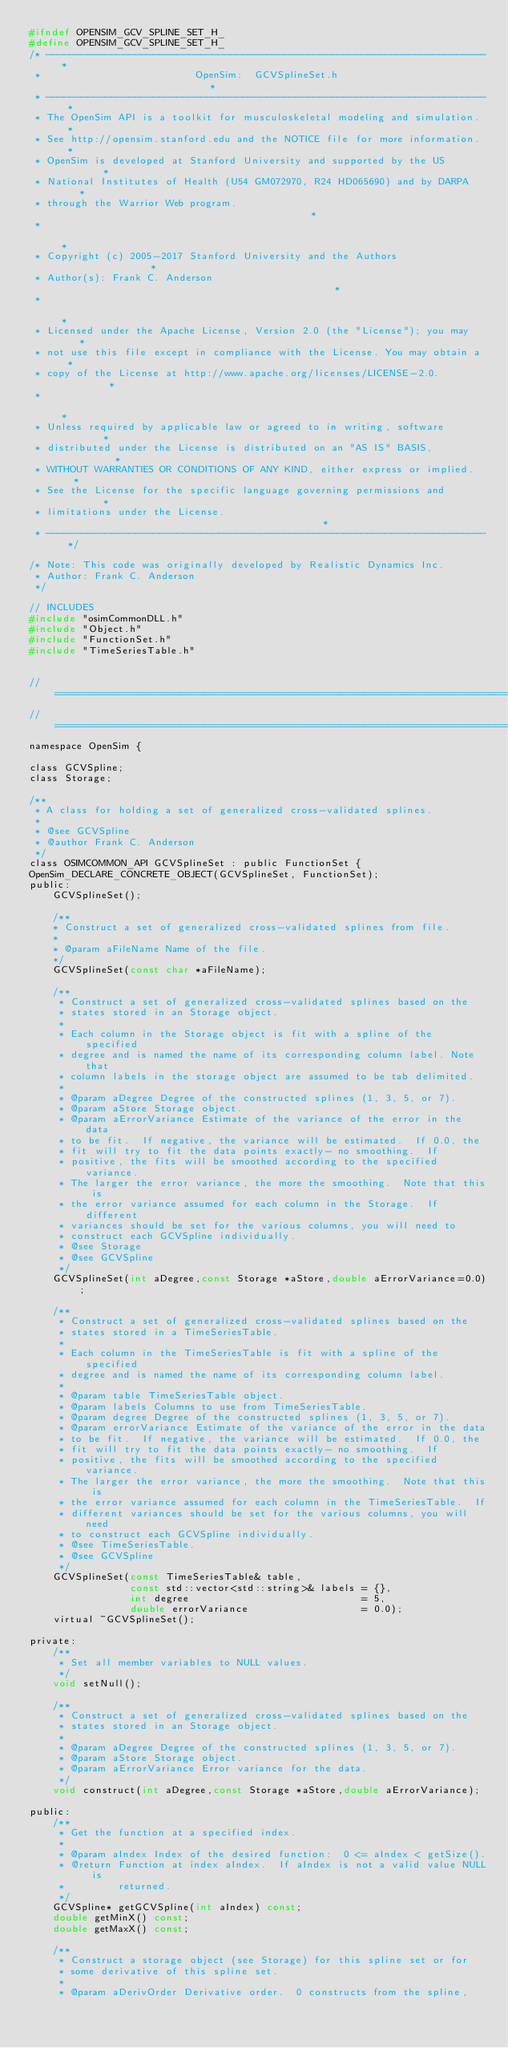<code> <loc_0><loc_0><loc_500><loc_500><_C_>#ifndef OPENSIM_GCV_SPLINE_SET_H_
#define OPENSIM_GCV_SPLINE_SET_H_
/* -------------------------------------------------------------------------- *
 *                          OpenSim:  GCVSplineSet.h                          *
 * -------------------------------------------------------------------------- *
 * The OpenSim API is a toolkit for musculoskeletal modeling and simulation.  *
 * See http://opensim.stanford.edu and the NOTICE file for more information.  *
 * OpenSim is developed at Stanford University and supported by the US        *
 * National Institutes of Health (U54 GM072970, R24 HD065690) and by DARPA    *
 * through the Warrior Web program.                                           *
 *                                                                            *
 * Copyright (c) 2005-2017 Stanford University and the Authors                *
 * Author(s): Frank C. Anderson                                               *
 *                                                                            *
 * Licensed under the Apache License, Version 2.0 (the "License"); you may    *
 * not use this file except in compliance with the License. You may obtain a  *
 * copy of the License at http://www.apache.org/licenses/LICENSE-2.0.         *
 *                                                                            *
 * Unless required by applicable law or agreed to in writing, software        *
 * distributed under the License is distributed on an "AS IS" BASIS,          *
 * WITHOUT WARRANTIES OR CONDITIONS OF ANY KIND, either express or implied.   *
 * See the License for the specific language governing permissions and        *
 * limitations under the License.                                             *
 * -------------------------------------------------------------------------- */

/* Note: This code was originally developed by Realistic Dynamics Inc. 
 * Author: Frank C. Anderson 
 */

// INCLUDES
#include "osimCommonDLL.h"
#include "Object.h"
#include "FunctionSet.h"
#include "TimeSeriesTable.h"


//=============================================================================
//=============================================================================
namespace OpenSim { 

class GCVSpline;
class Storage;

/**
 * A class for holding a set of generalized cross-validated splines.
 *
 * @see GCVSpline
 * @author Frank C. Anderson
 */
class OSIMCOMMON_API GCVSplineSet : public FunctionSet {
OpenSim_DECLARE_CONCRETE_OBJECT(GCVSplineSet, FunctionSet);
public:
    GCVSplineSet();

    /**
    * Construct a set of generalized cross-validated splines from file.
    *
    * @param aFileName Name of the file.
    */
    GCVSplineSet(const char *aFileName);

    /**
     * Construct a set of generalized cross-validated splines based on the 
     * states stored in an Storage object.
     *
     * Each column in the Storage object is fit with a spline of the specified
     * degree and is named the name of its corresponding column label. Note that
     * column labels in the storage object are assumed to be tab delimited.
     *
     * @param aDegree Degree of the constructed splines (1, 3, 5, or 7).
     * @param aStore Storage object.
     * @param aErrorVariance Estimate of the variance of the error in the data 
     * to be fit.  If negative, the variance will be estimated.  If 0.0, the 
     * fit will try to fit the data points exactly- no smoothing.  If
     * positive, the fits will be smoothed according to the specified variance.
     * The larger the error variance, the more the smoothing.  Note that this is
     * the error variance assumed for each column in the Storage.  If different
     * variances should be set for the various columns, you will need to
     * construct each GCVSpline individually.
     * @see Storage
     * @see GCVSpline
     */
    GCVSplineSet(int aDegree,const Storage *aStore,double aErrorVariance=0.0);

    /**
     * Construct a set of generalized cross-validated splines based on the 
     * states stored in a TimeSeriesTable.
     *
     * Each column in the TimeSeriesTable is fit with a spline of the specified
     * degree and is named the name of its corresponding column label.  
     *
     * @param table TimeSeriesTable object.
     * @param labels Columns to use from TimeSeriesTable.
     * @param degree Degree of the constructed splines (1, 3, 5, or 7).
     * @param errorVariance Estimate of the variance of the error in the data 
     * to be fit.  If negative, the variance will be estimated.  If 0.0, the 
     * fit will try to fit the data points exactly- no smoothing.  If
     * positive, the fits will be smoothed according to the specified variance.
     * The larger the error variance, the more the smoothing.  Note that this is
     * the error variance assumed for each column in the TimeSeriesTable.  If 
     * different variances should be set for the various columns, you will need 
     * to construct each GCVSpline individually.
     * @see TimeSeriesTable.
     * @see GCVSpline
     */
    GCVSplineSet(const TimeSeriesTable& table,
                 const std::vector<std::string>& labels = {},
                 int degree                             = 5,
                 double errorVariance                   = 0.0);
    virtual ~GCVSplineSet();

private:
    /**
     * Set all member variables to NULL values.
     */
    void setNull();

    /**
     * Construct a set of generalized cross-validated splines based on the 
     * states stored in an Storage object.
     *
     * @param aDegree Degree of the constructed splines (1, 3, 5, or 7).
     * @param aStore Storage object.
     * @param aErrorVariance Error variance for the data.
     */
    void construct(int aDegree,const Storage *aStore,double aErrorVariance);

public:
    /**
     * Get the function at a specified index.
     *
     * @param aIndex Index of the desired function:  0 <= aIndex < getSize().
     * @return Function at index aIndex.  If aIndex is not a valid value NULL is
     *         returned.
     */
    GCVSpline* getGCVSpline(int aIndex) const;
    double getMinX() const;
    double getMaxX() const;

    /**
     * Construct a storage object (see Storage) for this spline set or for 
     * some derivative of this spline set.
     *
     * @param aDerivOrder Derivative order.  0 constructs from the spline,</code> 